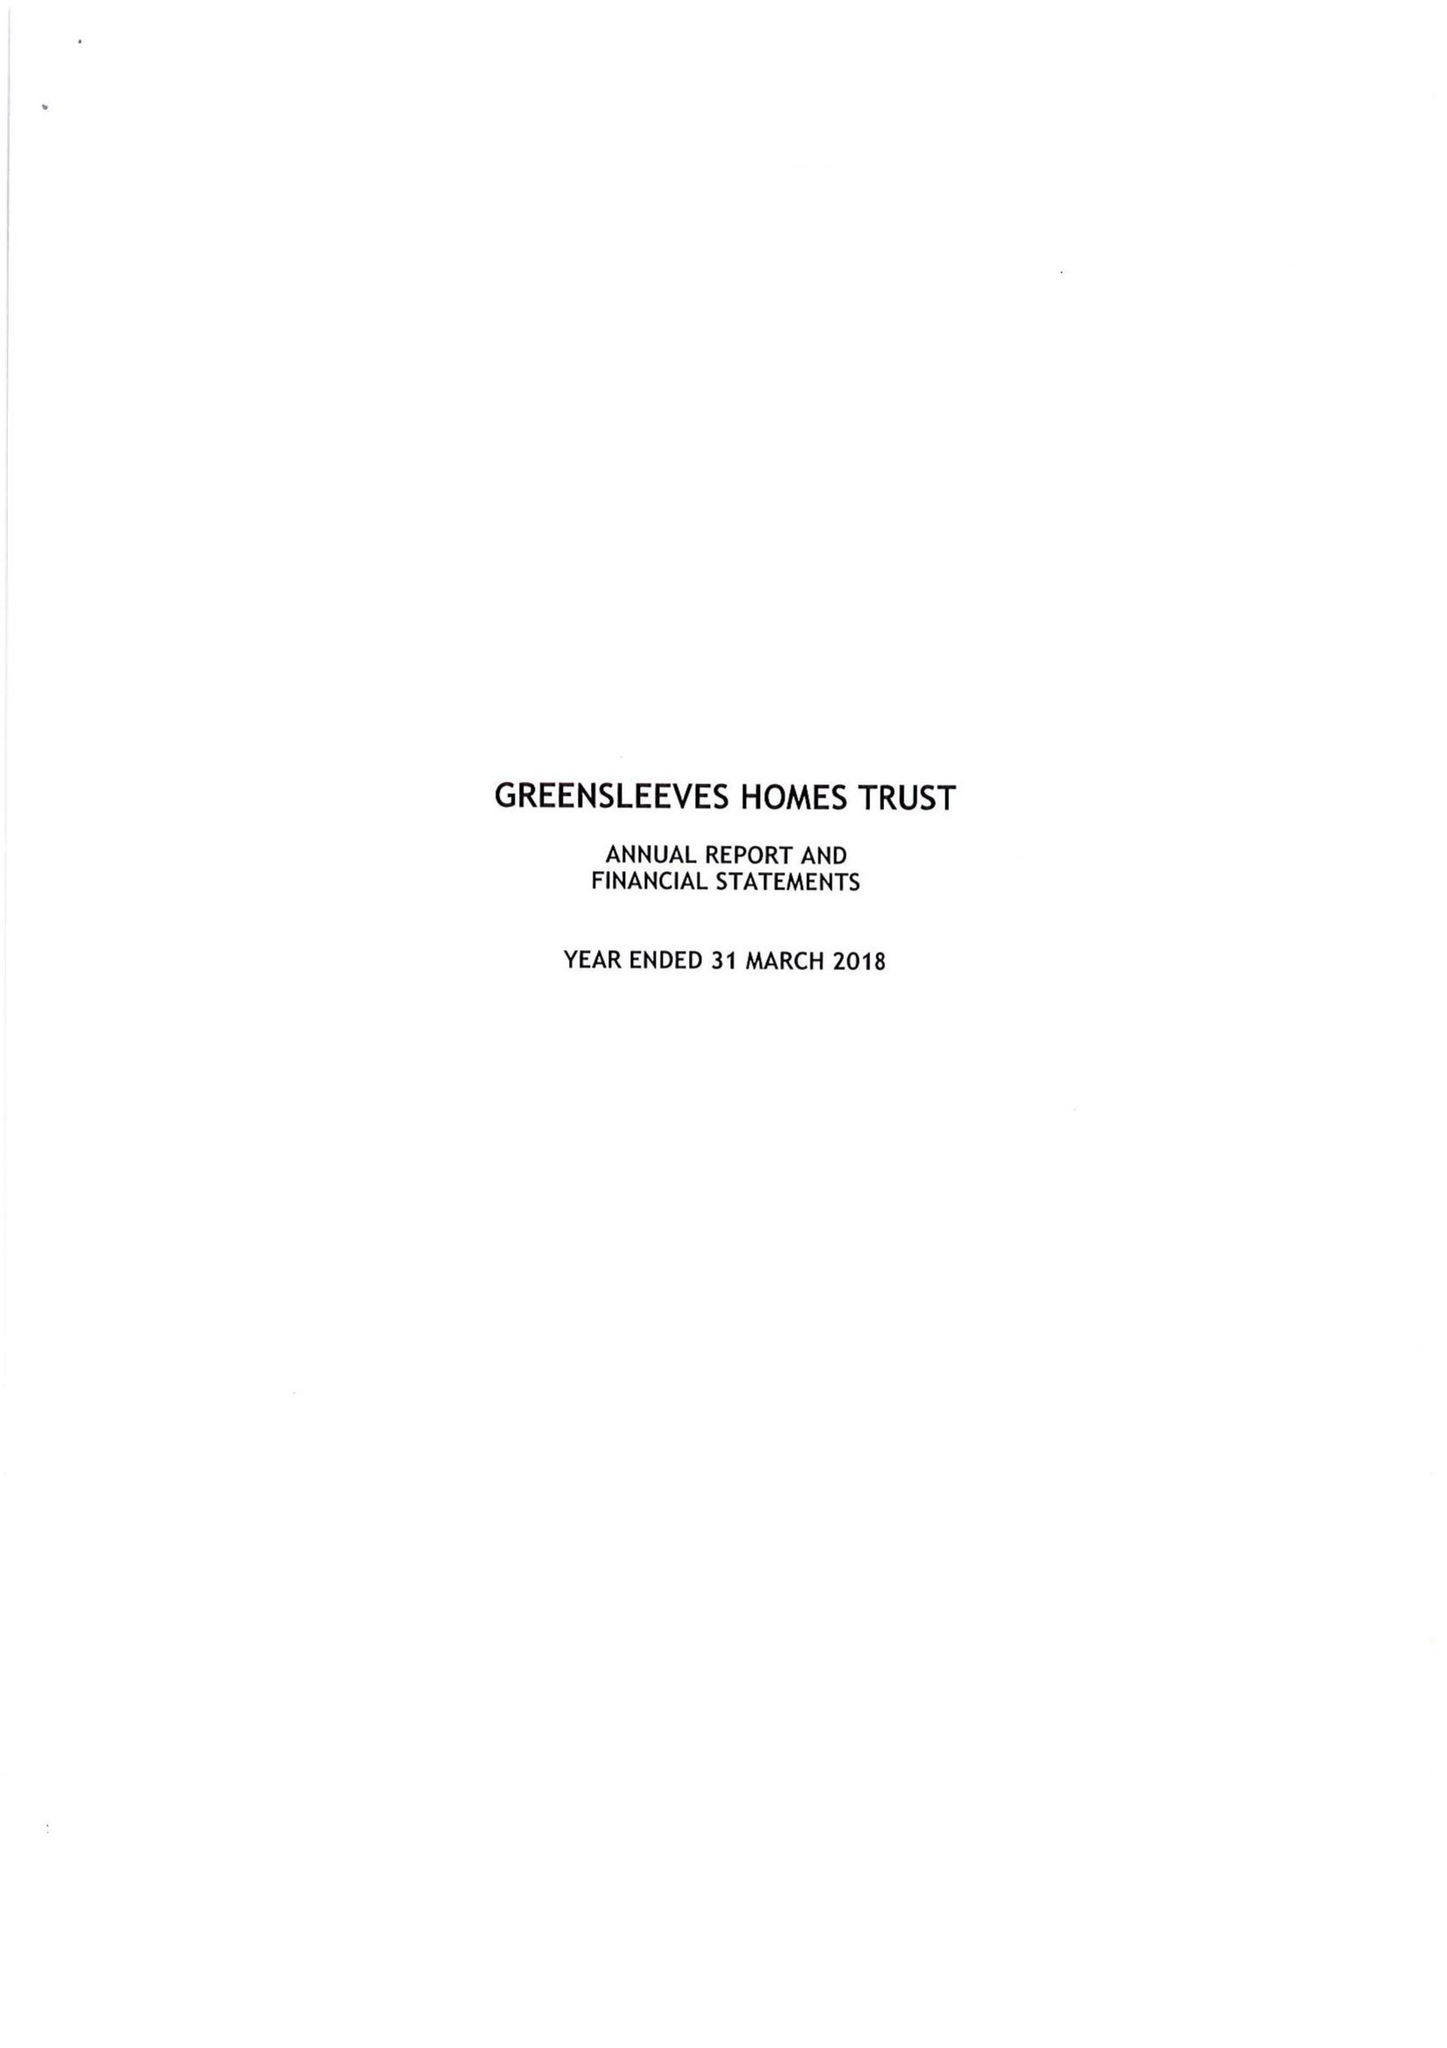What is the value for the address__post_town?
Answer the question using a single word or phrase. LONDON 